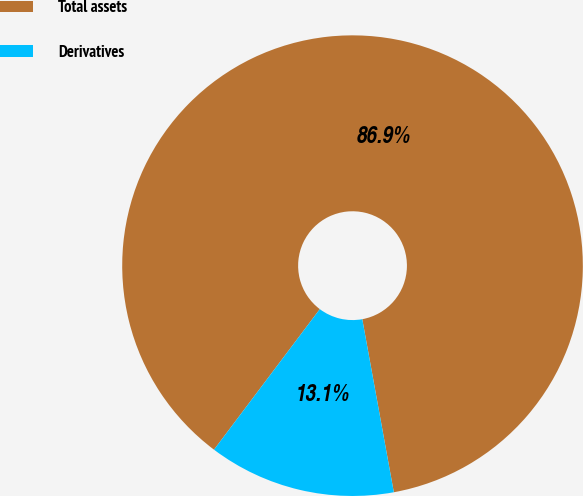Convert chart to OTSL. <chart><loc_0><loc_0><loc_500><loc_500><pie_chart><fcel>Total assets<fcel>Derivatives<nl><fcel>86.86%<fcel>13.14%<nl></chart> 